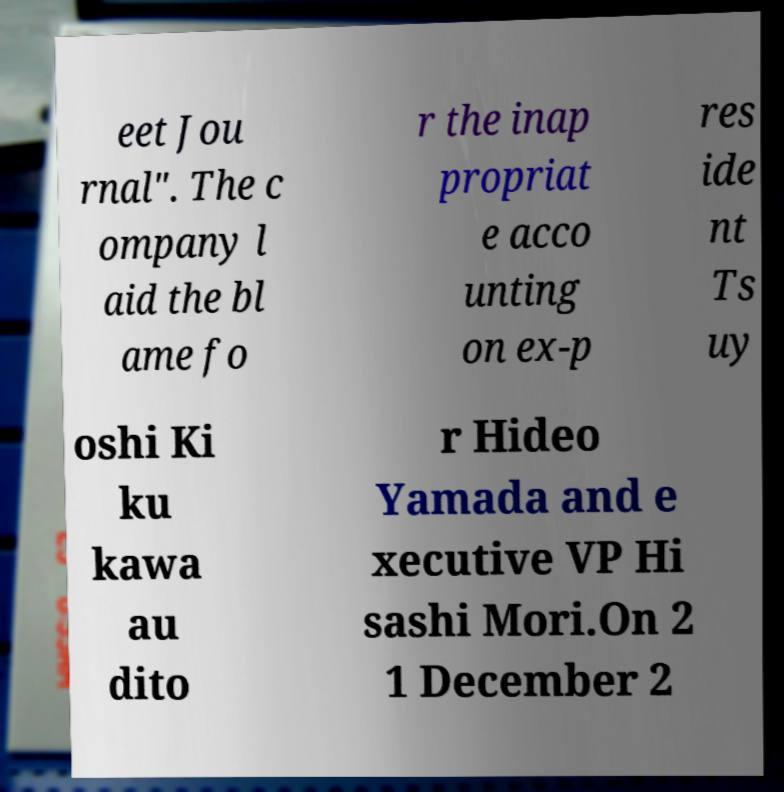Could you extract and type out the text from this image? eet Jou rnal". The c ompany l aid the bl ame fo r the inap propriat e acco unting on ex-p res ide nt Ts uy oshi Ki ku kawa au dito r Hideo Yamada and e xecutive VP Hi sashi Mori.On 2 1 December 2 